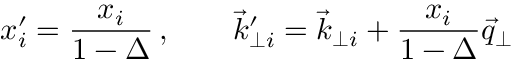Convert formula to latex. <formula><loc_0><loc_0><loc_500><loc_500>x _ { i } ^ { \prime } = { \frac { x _ { i } } { 1 - \Delta } } \, , \quad { \vec { k } } _ { \perp i } ^ { \prime } = { \vec { k } } _ { \perp i } + { \frac { x _ { i } } { 1 - \Delta } } { \vec { q } } _ { \perp }</formula> 